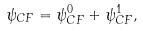Convert formula to latex. <formula><loc_0><loc_0><loc_500><loc_500>\psi _ { C F } = \psi _ { C F } ^ { 0 } + \psi _ { C F } ^ { 1 } ,</formula> 